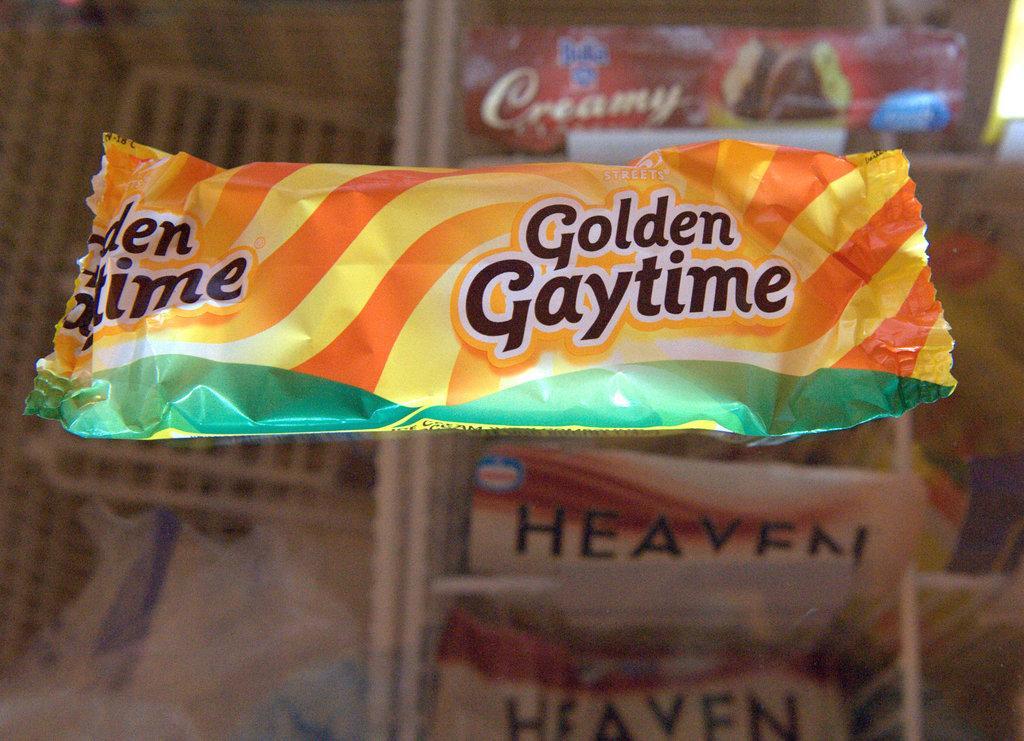In one or two sentences, can you explain what this image depicts? In this image we can see a cover with some text placed on the surface. In the background, we can see some boxes and bags placed on racks. 